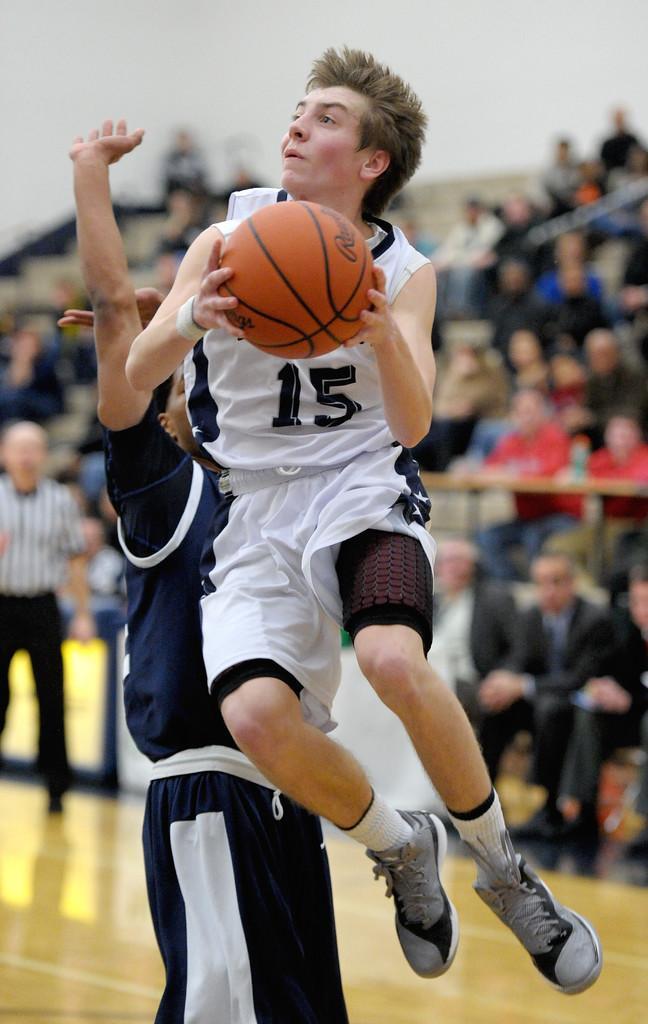How would you summarize this image in a sentence or two? In this picture I can see a man is holding a ball in the hand. This person is in the air. This person is wearing white color clothes. In the background I can see people sitting and a person is standing on the floor. 